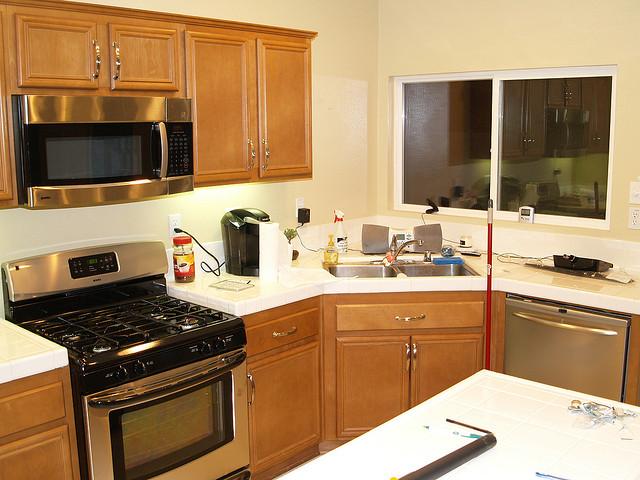On which side of the picture is the dishwasher?
Concise answer only. Right. Is the stove black?
Keep it brief. Yes. Are there curtains on the window?
Concise answer only. No. Is this a fancy kitchen?
Answer briefly. No. Is there a dining area in this kitchen?
Quick response, please. No. Does anyone live in this home?
Concise answer only. Yes. 